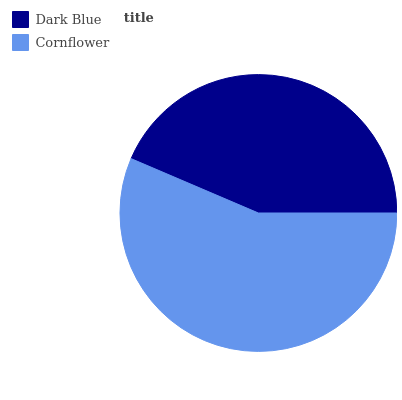Is Dark Blue the minimum?
Answer yes or no. Yes. Is Cornflower the maximum?
Answer yes or no. Yes. Is Cornflower the minimum?
Answer yes or no. No. Is Cornflower greater than Dark Blue?
Answer yes or no. Yes. Is Dark Blue less than Cornflower?
Answer yes or no. Yes. Is Dark Blue greater than Cornflower?
Answer yes or no. No. Is Cornflower less than Dark Blue?
Answer yes or no. No. Is Cornflower the high median?
Answer yes or no. Yes. Is Dark Blue the low median?
Answer yes or no. Yes. Is Dark Blue the high median?
Answer yes or no. No. Is Cornflower the low median?
Answer yes or no. No. 